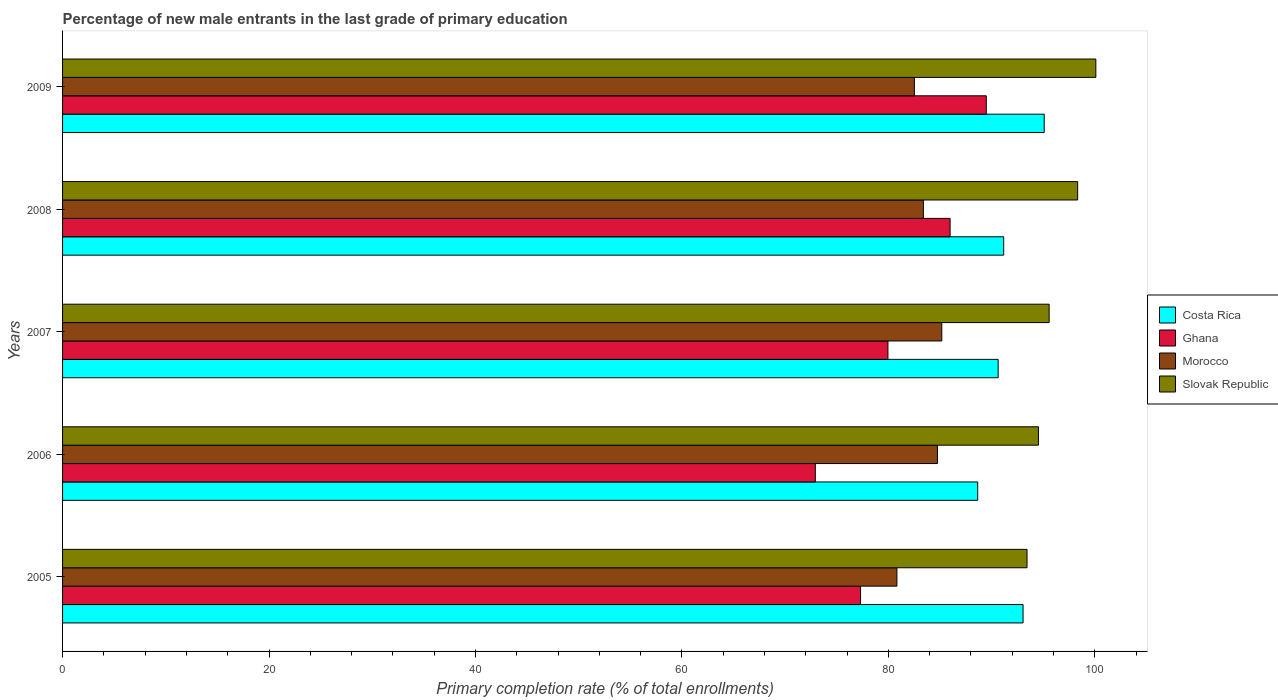Are the number of bars per tick equal to the number of legend labels?
Your response must be concise. Yes. Are the number of bars on each tick of the Y-axis equal?
Ensure brevity in your answer.  Yes. How many bars are there on the 2nd tick from the top?
Give a very brief answer. 4. How many bars are there on the 5th tick from the bottom?
Your answer should be very brief. 4. In how many cases, is the number of bars for a given year not equal to the number of legend labels?
Your answer should be very brief. 0. What is the percentage of new male entrants in Costa Rica in 2009?
Keep it short and to the point. 95.1. Across all years, what is the maximum percentage of new male entrants in Ghana?
Your response must be concise. 89.49. Across all years, what is the minimum percentage of new male entrants in Slovak Republic?
Offer a very short reply. 93.44. In which year was the percentage of new male entrants in Ghana maximum?
Offer a terse response. 2009. In which year was the percentage of new male entrants in Costa Rica minimum?
Your answer should be compact. 2006. What is the total percentage of new male entrants in Slovak Republic in the graph?
Provide a succinct answer. 482.03. What is the difference between the percentage of new male entrants in Morocco in 2005 and that in 2006?
Your answer should be compact. -3.93. What is the difference between the percentage of new male entrants in Ghana in 2006 and the percentage of new male entrants in Morocco in 2008?
Provide a succinct answer. -10.46. What is the average percentage of new male entrants in Ghana per year?
Your response must be concise. 81.14. In the year 2009, what is the difference between the percentage of new male entrants in Ghana and percentage of new male entrants in Morocco?
Make the answer very short. 6.97. In how many years, is the percentage of new male entrants in Ghana greater than 16 %?
Your answer should be very brief. 5. What is the ratio of the percentage of new male entrants in Slovak Republic in 2007 to that in 2009?
Your answer should be very brief. 0.95. Is the percentage of new male entrants in Ghana in 2006 less than that in 2008?
Provide a short and direct response. Yes. What is the difference between the highest and the second highest percentage of new male entrants in Costa Rica?
Provide a succinct answer. 2.05. What is the difference between the highest and the lowest percentage of new male entrants in Costa Rica?
Offer a very short reply. 6.44. In how many years, is the percentage of new male entrants in Costa Rica greater than the average percentage of new male entrants in Costa Rica taken over all years?
Your answer should be very brief. 2. Is the sum of the percentage of new male entrants in Morocco in 2005 and 2008 greater than the maximum percentage of new male entrants in Slovak Republic across all years?
Keep it short and to the point. Yes. Is it the case that in every year, the sum of the percentage of new male entrants in Morocco and percentage of new male entrants in Costa Rica is greater than the sum of percentage of new male entrants in Ghana and percentage of new male entrants in Slovak Republic?
Your answer should be compact. Yes. What does the 4th bar from the top in 2008 represents?
Your answer should be compact. Costa Rica. What does the 3rd bar from the bottom in 2008 represents?
Provide a short and direct response. Morocco. What is the difference between two consecutive major ticks on the X-axis?
Provide a succinct answer. 20. Where does the legend appear in the graph?
Your answer should be very brief. Center right. How are the legend labels stacked?
Give a very brief answer. Vertical. What is the title of the graph?
Make the answer very short. Percentage of new male entrants in the last grade of primary education. What is the label or title of the X-axis?
Make the answer very short. Primary completion rate (% of total enrollments). What is the Primary completion rate (% of total enrollments) of Costa Rica in 2005?
Provide a short and direct response. 93.06. What is the Primary completion rate (% of total enrollments) in Ghana in 2005?
Provide a short and direct response. 77.31. What is the Primary completion rate (% of total enrollments) of Morocco in 2005?
Give a very brief answer. 80.83. What is the Primary completion rate (% of total enrollments) of Slovak Republic in 2005?
Provide a short and direct response. 93.44. What is the Primary completion rate (% of total enrollments) in Costa Rica in 2006?
Provide a succinct answer. 88.66. What is the Primary completion rate (% of total enrollments) of Ghana in 2006?
Your response must be concise. 72.93. What is the Primary completion rate (% of total enrollments) of Morocco in 2006?
Provide a succinct answer. 84.76. What is the Primary completion rate (% of total enrollments) of Slovak Republic in 2006?
Provide a succinct answer. 94.55. What is the Primary completion rate (% of total enrollments) in Costa Rica in 2007?
Keep it short and to the point. 90.64. What is the Primary completion rate (% of total enrollments) in Ghana in 2007?
Give a very brief answer. 79.97. What is the Primary completion rate (% of total enrollments) in Morocco in 2007?
Provide a short and direct response. 85.18. What is the Primary completion rate (% of total enrollments) of Slovak Republic in 2007?
Your answer should be compact. 95.58. What is the Primary completion rate (% of total enrollments) of Costa Rica in 2008?
Your response must be concise. 91.18. What is the Primary completion rate (% of total enrollments) of Ghana in 2008?
Make the answer very short. 85.99. What is the Primary completion rate (% of total enrollments) in Morocco in 2008?
Offer a terse response. 83.4. What is the Primary completion rate (% of total enrollments) of Slovak Republic in 2008?
Your response must be concise. 98.35. What is the Primary completion rate (% of total enrollments) in Costa Rica in 2009?
Give a very brief answer. 95.1. What is the Primary completion rate (% of total enrollments) of Ghana in 2009?
Your response must be concise. 89.49. What is the Primary completion rate (% of total enrollments) of Morocco in 2009?
Your response must be concise. 82.53. What is the Primary completion rate (% of total enrollments) in Slovak Republic in 2009?
Offer a very short reply. 100.11. Across all years, what is the maximum Primary completion rate (% of total enrollments) in Costa Rica?
Keep it short and to the point. 95.1. Across all years, what is the maximum Primary completion rate (% of total enrollments) in Ghana?
Your answer should be compact. 89.49. Across all years, what is the maximum Primary completion rate (% of total enrollments) of Morocco?
Keep it short and to the point. 85.18. Across all years, what is the maximum Primary completion rate (% of total enrollments) of Slovak Republic?
Your answer should be very brief. 100.11. Across all years, what is the minimum Primary completion rate (% of total enrollments) of Costa Rica?
Offer a very short reply. 88.66. Across all years, what is the minimum Primary completion rate (% of total enrollments) in Ghana?
Give a very brief answer. 72.93. Across all years, what is the minimum Primary completion rate (% of total enrollments) in Morocco?
Ensure brevity in your answer.  80.83. Across all years, what is the minimum Primary completion rate (% of total enrollments) of Slovak Republic?
Keep it short and to the point. 93.44. What is the total Primary completion rate (% of total enrollments) of Costa Rica in the graph?
Provide a short and direct response. 458.65. What is the total Primary completion rate (% of total enrollments) of Ghana in the graph?
Ensure brevity in your answer.  405.69. What is the total Primary completion rate (% of total enrollments) of Morocco in the graph?
Offer a very short reply. 416.71. What is the total Primary completion rate (% of total enrollments) in Slovak Republic in the graph?
Offer a terse response. 482.03. What is the difference between the Primary completion rate (% of total enrollments) of Costa Rica in 2005 and that in 2006?
Provide a succinct answer. 4.39. What is the difference between the Primary completion rate (% of total enrollments) of Ghana in 2005 and that in 2006?
Offer a terse response. 4.38. What is the difference between the Primary completion rate (% of total enrollments) of Morocco in 2005 and that in 2006?
Your answer should be compact. -3.93. What is the difference between the Primary completion rate (% of total enrollments) in Slovak Republic in 2005 and that in 2006?
Your response must be concise. -1.11. What is the difference between the Primary completion rate (% of total enrollments) in Costa Rica in 2005 and that in 2007?
Give a very brief answer. 2.41. What is the difference between the Primary completion rate (% of total enrollments) of Ghana in 2005 and that in 2007?
Provide a succinct answer. -2.65. What is the difference between the Primary completion rate (% of total enrollments) of Morocco in 2005 and that in 2007?
Make the answer very short. -4.35. What is the difference between the Primary completion rate (% of total enrollments) in Slovak Republic in 2005 and that in 2007?
Make the answer very short. -2.14. What is the difference between the Primary completion rate (% of total enrollments) of Costa Rica in 2005 and that in 2008?
Give a very brief answer. 1.88. What is the difference between the Primary completion rate (% of total enrollments) of Ghana in 2005 and that in 2008?
Make the answer very short. -8.67. What is the difference between the Primary completion rate (% of total enrollments) in Morocco in 2005 and that in 2008?
Your answer should be compact. -2.56. What is the difference between the Primary completion rate (% of total enrollments) in Slovak Republic in 2005 and that in 2008?
Offer a terse response. -4.91. What is the difference between the Primary completion rate (% of total enrollments) in Costa Rica in 2005 and that in 2009?
Offer a very short reply. -2.05. What is the difference between the Primary completion rate (% of total enrollments) of Ghana in 2005 and that in 2009?
Offer a very short reply. -12.18. What is the difference between the Primary completion rate (% of total enrollments) in Morocco in 2005 and that in 2009?
Keep it short and to the point. -1.69. What is the difference between the Primary completion rate (% of total enrollments) in Slovak Republic in 2005 and that in 2009?
Provide a short and direct response. -6.67. What is the difference between the Primary completion rate (% of total enrollments) of Costa Rica in 2006 and that in 2007?
Your answer should be very brief. -1.98. What is the difference between the Primary completion rate (% of total enrollments) in Ghana in 2006 and that in 2007?
Your response must be concise. -7.03. What is the difference between the Primary completion rate (% of total enrollments) of Morocco in 2006 and that in 2007?
Make the answer very short. -0.42. What is the difference between the Primary completion rate (% of total enrollments) of Slovak Republic in 2006 and that in 2007?
Your answer should be very brief. -1.03. What is the difference between the Primary completion rate (% of total enrollments) of Costa Rica in 2006 and that in 2008?
Offer a terse response. -2.52. What is the difference between the Primary completion rate (% of total enrollments) in Ghana in 2006 and that in 2008?
Your response must be concise. -13.06. What is the difference between the Primary completion rate (% of total enrollments) of Morocco in 2006 and that in 2008?
Give a very brief answer. 1.37. What is the difference between the Primary completion rate (% of total enrollments) of Slovak Republic in 2006 and that in 2008?
Offer a very short reply. -3.8. What is the difference between the Primary completion rate (% of total enrollments) in Costa Rica in 2006 and that in 2009?
Provide a short and direct response. -6.44. What is the difference between the Primary completion rate (% of total enrollments) in Ghana in 2006 and that in 2009?
Keep it short and to the point. -16.56. What is the difference between the Primary completion rate (% of total enrollments) of Morocco in 2006 and that in 2009?
Your response must be concise. 2.24. What is the difference between the Primary completion rate (% of total enrollments) in Slovak Republic in 2006 and that in 2009?
Keep it short and to the point. -5.56. What is the difference between the Primary completion rate (% of total enrollments) of Costa Rica in 2007 and that in 2008?
Provide a short and direct response. -0.54. What is the difference between the Primary completion rate (% of total enrollments) of Ghana in 2007 and that in 2008?
Keep it short and to the point. -6.02. What is the difference between the Primary completion rate (% of total enrollments) of Morocco in 2007 and that in 2008?
Make the answer very short. 1.79. What is the difference between the Primary completion rate (% of total enrollments) of Slovak Republic in 2007 and that in 2008?
Keep it short and to the point. -2.76. What is the difference between the Primary completion rate (% of total enrollments) of Costa Rica in 2007 and that in 2009?
Your response must be concise. -4.46. What is the difference between the Primary completion rate (% of total enrollments) in Ghana in 2007 and that in 2009?
Keep it short and to the point. -9.53. What is the difference between the Primary completion rate (% of total enrollments) in Morocco in 2007 and that in 2009?
Your answer should be compact. 2.65. What is the difference between the Primary completion rate (% of total enrollments) in Slovak Republic in 2007 and that in 2009?
Make the answer very short. -4.53. What is the difference between the Primary completion rate (% of total enrollments) in Costa Rica in 2008 and that in 2009?
Offer a terse response. -3.92. What is the difference between the Primary completion rate (% of total enrollments) in Ghana in 2008 and that in 2009?
Make the answer very short. -3.51. What is the difference between the Primary completion rate (% of total enrollments) in Morocco in 2008 and that in 2009?
Make the answer very short. 0.87. What is the difference between the Primary completion rate (% of total enrollments) in Slovak Republic in 2008 and that in 2009?
Your response must be concise. -1.76. What is the difference between the Primary completion rate (% of total enrollments) of Costa Rica in 2005 and the Primary completion rate (% of total enrollments) of Ghana in 2006?
Give a very brief answer. 20.13. What is the difference between the Primary completion rate (% of total enrollments) in Costa Rica in 2005 and the Primary completion rate (% of total enrollments) in Morocco in 2006?
Keep it short and to the point. 8.29. What is the difference between the Primary completion rate (% of total enrollments) of Costa Rica in 2005 and the Primary completion rate (% of total enrollments) of Slovak Republic in 2006?
Make the answer very short. -1.49. What is the difference between the Primary completion rate (% of total enrollments) of Ghana in 2005 and the Primary completion rate (% of total enrollments) of Morocco in 2006?
Your answer should be very brief. -7.45. What is the difference between the Primary completion rate (% of total enrollments) of Ghana in 2005 and the Primary completion rate (% of total enrollments) of Slovak Republic in 2006?
Provide a succinct answer. -17.24. What is the difference between the Primary completion rate (% of total enrollments) of Morocco in 2005 and the Primary completion rate (% of total enrollments) of Slovak Republic in 2006?
Your answer should be very brief. -13.71. What is the difference between the Primary completion rate (% of total enrollments) of Costa Rica in 2005 and the Primary completion rate (% of total enrollments) of Ghana in 2007?
Your answer should be very brief. 13.09. What is the difference between the Primary completion rate (% of total enrollments) of Costa Rica in 2005 and the Primary completion rate (% of total enrollments) of Morocco in 2007?
Provide a short and direct response. 7.88. What is the difference between the Primary completion rate (% of total enrollments) of Costa Rica in 2005 and the Primary completion rate (% of total enrollments) of Slovak Republic in 2007?
Ensure brevity in your answer.  -2.53. What is the difference between the Primary completion rate (% of total enrollments) in Ghana in 2005 and the Primary completion rate (% of total enrollments) in Morocco in 2007?
Give a very brief answer. -7.87. What is the difference between the Primary completion rate (% of total enrollments) in Ghana in 2005 and the Primary completion rate (% of total enrollments) in Slovak Republic in 2007?
Make the answer very short. -18.27. What is the difference between the Primary completion rate (% of total enrollments) of Morocco in 2005 and the Primary completion rate (% of total enrollments) of Slovak Republic in 2007?
Give a very brief answer. -14.75. What is the difference between the Primary completion rate (% of total enrollments) in Costa Rica in 2005 and the Primary completion rate (% of total enrollments) in Ghana in 2008?
Offer a terse response. 7.07. What is the difference between the Primary completion rate (% of total enrollments) in Costa Rica in 2005 and the Primary completion rate (% of total enrollments) in Morocco in 2008?
Your answer should be very brief. 9.66. What is the difference between the Primary completion rate (% of total enrollments) of Costa Rica in 2005 and the Primary completion rate (% of total enrollments) of Slovak Republic in 2008?
Provide a short and direct response. -5.29. What is the difference between the Primary completion rate (% of total enrollments) in Ghana in 2005 and the Primary completion rate (% of total enrollments) in Morocco in 2008?
Ensure brevity in your answer.  -6.08. What is the difference between the Primary completion rate (% of total enrollments) in Ghana in 2005 and the Primary completion rate (% of total enrollments) in Slovak Republic in 2008?
Give a very brief answer. -21.03. What is the difference between the Primary completion rate (% of total enrollments) in Morocco in 2005 and the Primary completion rate (% of total enrollments) in Slovak Republic in 2008?
Offer a very short reply. -17.51. What is the difference between the Primary completion rate (% of total enrollments) of Costa Rica in 2005 and the Primary completion rate (% of total enrollments) of Ghana in 2009?
Ensure brevity in your answer.  3.56. What is the difference between the Primary completion rate (% of total enrollments) of Costa Rica in 2005 and the Primary completion rate (% of total enrollments) of Morocco in 2009?
Keep it short and to the point. 10.53. What is the difference between the Primary completion rate (% of total enrollments) in Costa Rica in 2005 and the Primary completion rate (% of total enrollments) in Slovak Republic in 2009?
Provide a succinct answer. -7.05. What is the difference between the Primary completion rate (% of total enrollments) of Ghana in 2005 and the Primary completion rate (% of total enrollments) of Morocco in 2009?
Make the answer very short. -5.22. What is the difference between the Primary completion rate (% of total enrollments) of Ghana in 2005 and the Primary completion rate (% of total enrollments) of Slovak Republic in 2009?
Offer a very short reply. -22.8. What is the difference between the Primary completion rate (% of total enrollments) in Morocco in 2005 and the Primary completion rate (% of total enrollments) in Slovak Republic in 2009?
Offer a very short reply. -19.27. What is the difference between the Primary completion rate (% of total enrollments) of Costa Rica in 2006 and the Primary completion rate (% of total enrollments) of Ghana in 2007?
Your response must be concise. 8.7. What is the difference between the Primary completion rate (% of total enrollments) in Costa Rica in 2006 and the Primary completion rate (% of total enrollments) in Morocco in 2007?
Ensure brevity in your answer.  3.48. What is the difference between the Primary completion rate (% of total enrollments) of Costa Rica in 2006 and the Primary completion rate (% of total enrollments) of Slovak Republic in 2007?
Your response must be concise. -6.92. What is the difference between the Primary completion rate (% of total enrollments) of Ghana in 2006 and the Primary completion rate (% of total enrollments) of Morocco in 2007?
Your response must be concise. -12.25. What is the difference between the Primary completion rate (% of total enrollments) in Ghana in 2006 and the Primary completion rate (% of total enrollments) in Slovak Republic in 2007?
Ensure brevity in your answer.  -22.65. What is the difference between the Primary completion rate (% of total enrollments) in Morocco in 2006 and the Primary completion rate (% of total enrollments) in Slovak Republic in 2007?
Offer a terse response. -10.82. What is the difference between the Primary completion rate (% of total enrollments) in Costa Rica in 2006 and the Primary completion rate (% of total enrollments) in Ghana in 2008?
Provide a short and direct response. 2.67. What is the difference between the Primary completion rate (% of total enrollments) in Costa Rica in 2006 and the Primary completion rate (% of total enrollments) in Morocco in 2008?
Make the answer very short. 5.27. What is the difference between the Primary completion rate (% of total enrollments) of Costa Rica in 2006 and the Primary completion rate (% of total enrollments) of Slovak Republic in 2008?
Offer a terse response. -9.68. What is the difference between the Primary completion rate (% of total enrollments) in Ghana in 2006 and the Primary completion rate (% of total enrollments) in Morocco in 2008?
Ensure brevity in your answer.  -10.46. What is the difference between the Primary completion rate (% of total enrollments) of Ghana in 2006 and the Primary completion rate (% of total enrollments) of Slovak Republic in 2008?
Provide a succinct answer. -25.42. What is the difference between the Primary completion rate (% of total enrollments) in Morocco in 2006 and the Primary completion rate (% of total enrollments) in Slovak Republic in 2008?
Provide a short and direct response. -13.58. What is the difference between the Primary completion rate (% of total enrollments) in Costa Rica in 2006 and the Primary completion rate (% of total enrollments) in Ghana in 2009?
Offer a terse response. -0.83. What is the difference between the Primary completion rate (% of total enrollments) of Costa Rica in 2006 and the Primary completion rate (% of total enrollments) of Morocco in 2009?
Offer a terse response. 6.13. What is the difference between the Primary completion rate (% of total enrollments) in Costa Rica in 2006 and the Primary completion rate (% of total enrollments) in Slovak Republic in 2009?
Offer a very short reply. -11.45. What is the difference between the Primary completion rate (% of total enrollments) of Ghana in 2006 and the Primary completion rate (% of total enrollments) of Morocco in 2009?
Offer a very short reply. -9.6. What is the difference between the Primary completion rate (% of total enrollments) in Ghana in 2006 and the Primary completion rate (% of total enrollments) in Slovak Republic in 2009?
Keep it short and to the point. -27.18. What is the difference between the Primary completion rate (% of total enrollments) of Morocco in 2006 and the Primary completion rate (% of total enrollments) of Slovak Republic in 2009?
Offer a very short reply. -15.34. What is the difference between the Primary completion rate (% of total enrollments) of Costa Rica in 2007 and the Primary completion rate (% of total enrollments) of Ghana in 2008?
Give a very brief answer. 4.66. What is the difference between the Primary completion rate (% of total enrollments) of Costa Rica in 2007 and the Primary completion rate (% of total enrollments) of Morocco in 2008?
Your answer should be very brief. 7.25. What is the difference between the Primary completion rate (% of total enrollments) in Costa Rica in 2007 and the Primary completion rate (% of total enrollments) in Slovak Republic in 2008?
Ensure brevity in your answer.  -7.7. What is the difference between the Primary completion rate (% of total enrollments) of Ghana in 2007 and the Primary completion rate (% of total enrollments) of Morocco in 2008?
Your answer should be compact. -3.43. What is the difference between the Primary completion rate (% of total enrollments) in Ghana in 2007 and the Primary completion rate (% of total enrollments) in Slovak Republic in 2008?
Provide a short and direct response. -18.38. What is the difference between the Primary completion rate (% of total enrollments) in Morocco in 2007 and the Primary completion rate (% of total enrollments) in Slovak Republic in 2008?
Keep it short and to the point. -13.17. What is the difference between the Primary completion rate (% of total enrollments) of Costa Rica in 2007 and the Primary completion rate (% of total enrollments) of Ghana in 2009?
Your answer should be very brief. 1.15. What is the difference between the Primary completion rate (% of total enrollments) of Costa Rica in 2007 and the Primary completion rate (% of total enrollments) of Morocco in 2009?
Provide a succinct answer. 8.11. What is the difference between the Primary completion rate (% of total enrollments) in Costa Rica in 2007 and the Primary completion rate (% of total enrollments) in Slovak Republic in 2009?
Provide a succinct answer. -9.46. What is the difference between the Primary completion rate (% of total enrollments) in Ghana in 2007 and the Primary completion rate (% of total enrollments) in Morocco in 2009?
Your answer should be very brief. -2.56. What is the difference between the Primary completion rate (% of total enrollments) of Ghana in 2007 and the Primary completion rate (% of total enrollments) of Slovak Republic in 2009?
Your response must be concise. -20.14. What is the difference between the Primary completion rate (% of total enrollments) in Morocco in 2007 and the Primary completion rate (% of total enrollments) in Slovak Republic in 2009?
Provide a short and direct response. -14.93. What is the difference between the Primary completion rate (% of total enrollments) in Costa Rica in 2008 and the Primary completion rate (% of total enrollments) in Ghana in 2009?
Provide a succinct answer. 1.69. What is the difference between the Primary completion rate (% of total enrollments) of Costa Rica in 2008 and the Primary completion rate (% of total enrollments) of Morocco in 2009?
Make the answer very short. 8.65. What is the difference between the Primary completion rate (% of total enrollments) in Costa Rica in 2008 and the Primary completion rate (% of total enrollments) in Slovak Republic in 2009?
Your answer should be very brief. -8.93. What is the difference between the Primary completion rate (% of total enrollments) of Ghana in 2008 and the Primary completion rate (% of total enrollments) of Morocco in 2009?
Provide a succinct answer. 3.46. What is the difference between the Primary completion rate (% of total enrollments) in Ghana in 2008 and the Primary completion rate (% of total enrollments) in Slovak Republic in 2009?
Provide a short and direct response. -14.12. What is the difference between the Primary completion rate (% of total enrollments) in Morocco in 2008 and the Primary completion rate (% of total enrollments) in Slovak Republic in 2009?
Give a very brief answer. -16.71. What is the average Primary completion rate (% of total enrollments) in Costa Rica per year?
Make the answer very short. 91.73. What is the average Primary completion rate (% of total enrollments) in Ghana per year?
Offer a very short reply. 81.14. What is the average Primary completion rate (% of total enrollments) of Morocco per year?
Ensure brevity in your answer.  83.34. What is the average Primary completion rate (% of total enrollments) in Slovak Republic per year?
Offer a very short reply. 96.41. In the year 2005, what is the difference between the Primary completion rate (% of total enrollments) in Costa Rica and Primary completion rate (% of total enrollments) in Ghana?
Offer a very short reply. 15.74. In the year 2005, what is the difference between the Primary completion rate (% of total enrollments) of Costa Rica and Primary completion rate (% of total enrollments) of Morocco?
Offer a very short reply. 12.22. In the year 2005, what is the difference between the Primary completion rate (% of total enrollments) in Costa Rica and Primary completion rate (% of total enrollments) in Slovak Republic?
Offer a terse response. -0.38. In the year 2005, what is the difference between the Primary completion rate (% of total enrollments) of Ghana and Primary completion rate (% of total enrollments) of Morocco?
Give a very brief answer. -3.52. In the year 2005, what is the difference between the Primary completion rate (% of total enrollments) in Ghana and Primary completion rate (% of total enrollments) in Slovak Republic?
Keep it short and to the point. -16.13. In the year 2005, what is the difference between the Primary completion rate (% of total enrollments) in Morocco and Primary completion rate (% of total enrollments) in Slovak Republic?
Offer a terse response. -12.61. In the year 2006, what is the difference between the Primary completion rate (% of total enrollments) in Costa Rica and Primary completion rate (% of total enrollments) in Ghana?
Your answer should be very brief. 15.73. In the year 2006, what is the difference between the Primary completion rate (% of total enrollments) of Costa Rica and Primary completion rate (% of total enrollments) of Morocco?
Keep it short and to the point. 3.9. In the year 2006, what is the difference between the Primary completion rate (% of total enrollments) in Costa Rica and Primary completion rate (% of total enrollments) in Slovak Republic?
Make the answer very short. -5.89. In the year 2006, what is the difference between the Primary completion rate (% of total enrollments) in Ghana and Primary completion rate (% of total enrollments) in Morocco?
Ensure brevity in your answer.  -11.83. In the year 2006, what is the difference between the Primary completion rate (% of total enrollments) of Ghana and Primary completion rate (% of total enrollments) of Slovak Republic?
Provide a succinct answer. -21.62. In the year 2006, what is the difference between the Primary completion rate (% of total enrollments) in Morocco and Primary completion rate (% of total enrollments) in Slovak Republic?
Keep it short and to the point. -9.78. In the year 2007, what is the difference between the Primary completion rate (% of total enrollments) of Costa Rica and Primary completion rate (% of total enrollments) of Ghana?
Your response must be concise. 10.68. In the year 2007, what is the difference between the Primary completion rate (% of total enrollments) of Costa Rica and Primary completion rate (% of total enrollments) of Morocco?
Give a very brief answer. 5.46. In the year 2007, what is the difference between the Primary completion rate (% of total enrollments) in Costa Rica and Primary completion rate (% of total enrollments) in Slovak Republic?
Your response must be concise. -4.94. In the year 2007, what is the difference between the Primary completion rate (% of total enrollments) in Ghana and Primary completion rate (% of total enrollments) in Morocco?
Offer a terse response. -5.22. In the year 2007, what is the difference between the Primary completion rate (% of total enrollments) in Ghana and Primary completion rate (% of total enrollments) in Slovak Republic?
Your response must be concise. -15.62. In the year 2007, what is the difference between the Primary completion rate (% of total enrollments) in Morocco and Primary completion rate (% of total enrollments) in Slovak Republic?
Provide a short and direct response. -10.4. In the year 2008, what is the difference between the Primary completion rate (% of total enrollments) of Costa Rica and Primary completion rate (% of total enrollments) of Ghana?
Give a very brief answer. 5.19. In the year 2008, what is the difference between the Primary completion rate (% of total enrollments) of Costa Rica and Primary completion rate (% of total enrollments) of Morocco?
Make the answer very short. 7.79. In the year 2008, what is the difference between the Primary completion rate (% of total enrollments) in Costa Rica and Primary completion rate (% of total enrollments) in Slovak Republic?
Give a very brief answer. -7.17. In the year 2008, what is the difference between the Primary completion rate (% of total enrollments) of Ghana and Primary completion rate (% of total enrollments) of Morocco?
Provide a short and direct response. 2.59. In the year 2008, what is the difference between the Primary completion rate (% of total enrollments) of Ghana and Primary completion rate (% of total enrollments) of Slovak Republic?
Offer a terse response. -12.36. In the year 2008, what is the difference between the Primary completion rate (% of total enrollments) in Morocco and Primary completion rate (% of total enrollments) in Slovak Republic?
Offer a very short reply. -14.95. In the year 2009, what is the difference between the Primary completion rate (% of total enrollments) of Costa Rica and Primary completion rate (% of total enrollments) of Ghana?
Offer a terse response. 5.61. In the year 2009, what is the difference between the Primary completion rate (% of total enrollments) of Costa Rica and Primary completion rate (% of total enrollments) of Morocco?
Your answer should be compact. 12.58. In the year 2009, what is the difference between the Primary completion rate (% of total enrollments) of Costa Rica and Primary completion rate (% of total enrollments) of Slovak Republic?
Keep it short and to the point. -5. In the year 2009, what is the difference between the Primary completion rate (% of total enrollments) in Ghana and Primary completion rate (% of total enrollments) in Morocco?
Offer a terse response. 6.96. In the year 2009, what is the difference between the Primary completion rate (% of total enrollments) of Ghana and Primary completion rate (% of total enrollments) of Slovak Republic?
Provide a succinct answer. -10.61. In the year 2009, what is the difference between the Primary completion rate (% of total enrollments) of Morocco and Primary completion rate (% of total enrollments) of Slovak Republic?
Keep it short and to the point. -17.58. What is the ratio of the Primary completion rate (% of total enrollments) in Costa Rica in 2005 to that in 2006?
Ensure brevity in your answer.  1.05. What is the ratio of the Primary completion rate (% of total enrollments) in Ghana in 2005 to that in 2006?
Offer a terse response. 1.06. What is the ratio of the Primary completion rate (% of total enrollments) of Morocco in 2005 to that in 2006?
Keep it short and to the point. 0.95. What is the ratio of the Primary completion rate (% of total enrollments) of Slovak Republic in 2005 to that in 2006?
Ensure brevity in your answer.  0.99. What is the ratio of the Primary completion rate (% of total enrollments) in Costa Rica in 2005 to that in 2007?
Give a very brief answer. 1.03. What is the ratio of the Primary completion rate (% of total enrollments) in Ghana in 2005 to that in 2007?
Give a very brief answer. 0.97. What is the ratio of the Primary completion rate (% of total enrollments) in Morocco in 2005 to that in 2007?
Offer a very short reply. 0.95. What is the ratio of the Primary completion rate (% of total enrollments) in Slovak Republic in 2005 to that in 2007?
Give a very brief answer. 0.98. What is the ratio of the Primary completion rate (% of total enrollments) of Costa Rica in 2005 to that in 2008?
Offer a terse response. 1.02. What is the ratio of the Primary completion rate (% of total enrollments) in Ghana in 2005 to that in 2008?
Give a very brief answer. 0.9. What is the ratio of the Primary completion rate (% of total enrollments) in Morocco in 2005 to that in 2008?
Make the answer very short. 0.97. What is the ratio of the Primary completion rate (% of total enrollments) in Slovak Republic in 2005 to that in 2008?
Provide a succinct answer. 0.95. What is the ratio of the Primary completion rate (% of total enrollments) of Costa Rica in 2005 to that in 2009?
Your response must be concise. 0.98. What is the ratio of the Primary completion rate (% of total enrollments) in Ghana in 2005 to that in 2009?
Provide a succinct answer. 0.86. What is the ratio of the Primary completion rate (% of total enrollments) in Morocco in 2005 to that in 2009?
Keep it short and to the point. 0.98. What is the ratio of the Primary completion rate (% of total enrollments) in Slovak Republic in 2005 to that in 2009?
Make the answer very short. 0.93. What is the ratio of the Primary completion rate (% of total enrollments) in Costa Rica in 2006 to that in 2007?
Keep it short and to the point. 0.98. What is the ratio of the Primary completion rate (% of total enrollments) in Ghana in 2006 to that in 2007?
Make the answer very short. 0.91. What is the ratio of the Primary completion rate (% of total enrollments) of Morocco in 2006 to that in 2007?
Make the answer very short. 1. What is the ratio of the Primary completion rate (% of total enrollments) of Costa Rica in 2006 to that in 2008?
Your answer should be very brief. 0.97. What is the ratio of the Primary completion rate (% of total enrollments) of Ghana in 2006 to that in 2008?
Your response must be concise. 0.85. What is the ratio of the Primary completion rate (% of total enrollments) of Morocco in 2006 to that in 2008?
Your response must be concise. 1.02. What is the ratio of the Primary completion rate (% of total enrollments) of Slovak Republic in 2006 to that in 2008?
Provide a succinct answer. 0.96. What is the ratio of the Primary completion rate (% of total enrollments) of Costa Rica in 2006 to that in 2009?
Offer a very short reply. 0.93. What is the ratio of the Primary completion rate (% of total enrollments) of Ghana in 2006 to that in 2009?
Provide a short and direct response. 0.81. What is the ratio of the Primary completion rate (% of total enrollments) in Morocco in 2006 to that in 2009?
Offer a very short reply. 1.03. What is the ratio of the Primary completion rate (% of total enrollments) in Slovak Republic in 2006 to that in 2009?
Your answer should be very brief. 0.94. What is the ratio of the Primary completion rate (% of total enrollments) in Costa Rica in 2007 to that in 2008?
Offer a terse response. 0.99. What is the ratio of the Primary completion rate (% of total enrollments) of Morocco in 2007 to that in 2008?
Offer a terse response. 1.02. What is the ratio of the Primary completion rate (% of total enrollments) in Slovak Republic in 2007 to that in 2008?
Provide a short and direct response. 0.97. What is the ratio of the Primary completion rate (% of total enrollments) of Costa Rica in 2007 to that in 2009?
Your response must be concise. 0.95. What is the ratio of the Primary completion rate (% of total enrollments) of Ghana in 2007 to that in 2009?
Offer a very short reply. 0.89. What is the ratio of the Primary completion rate (% of total enrollments) of Morocco in 2007 to that in 2009?
Your answer should be very brief. 1.03. What is the ratio of the Primary completion rate (% of total enrollments) in Slovak Republic in 2007 to that in 2009?
Your response must be concise. 0.95. What is the ratio of the Primary completion rate (% of total enrollments) in Costa Rica in 2008 to that in 2009?
Give a very brief answer. 0.96. What is the ratio of the Primary completion rate (% of total enrollments) in Ghana in 2008 to that in 2009?
Offer a terse response. 0.96. What is the ratio of the Primary completion rate (% of total enrollments) in Morocco in 2008 to that in 2009?
Ensure brevity in your answer.  1.01. What is the ratio of the Primary completion rate (% of total enrollments) of Slovak Republic in 2008 to that in 2009?
Provide a succinct answer. 0.98. What is the difference between the highest and the second highest Primary completion rate (% of total enrollments) of Costa Rica?
Your answer should be very brief. 2.05. What is the difference between the highest and the second highest Primary completion rate (% of total enrollments) of Ghana?
Your response must be concise. 3.51. What is the difference between the highest and the second highest Primary completion rate (% of total enrollments) of Morocco?
Give a very brief answer. 0.42. What is the difference between the highest and the second highest Primary completion rate (% of total enrollments) of Slovak Republic?
Provide a succinct answer. 1.76. What is the difference between the highest and the lowest Primary completion rate (% of total enrollments) in Costa Rica?
Your answer should be very brief. 6.44. What is the difference between the highest and the lowest Primary completion rate (% of total enrollments) in Ghana?
Ensure brevity in your answer.  16.56. What is the difference between the highest and the lowest Primary completion rate (% of total enrollments) of Morocco?
Provide a short and direct response. 4.35. What is the difference between the highest and the lowest Primary completion rate (% of total enrollments) in Slovak Republic?
Offer a terse response. 6.67. 